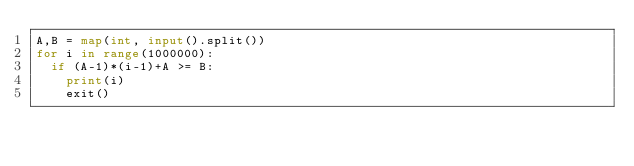Convert code to text. <code><loc_0><loc_0><loc_500><loc_500><_Python_>A,B = map(int, input().split())
for i in range(1000000):
  if (A-1)*(i-1)+A >= B:
    print(i)
    exit()</code> 